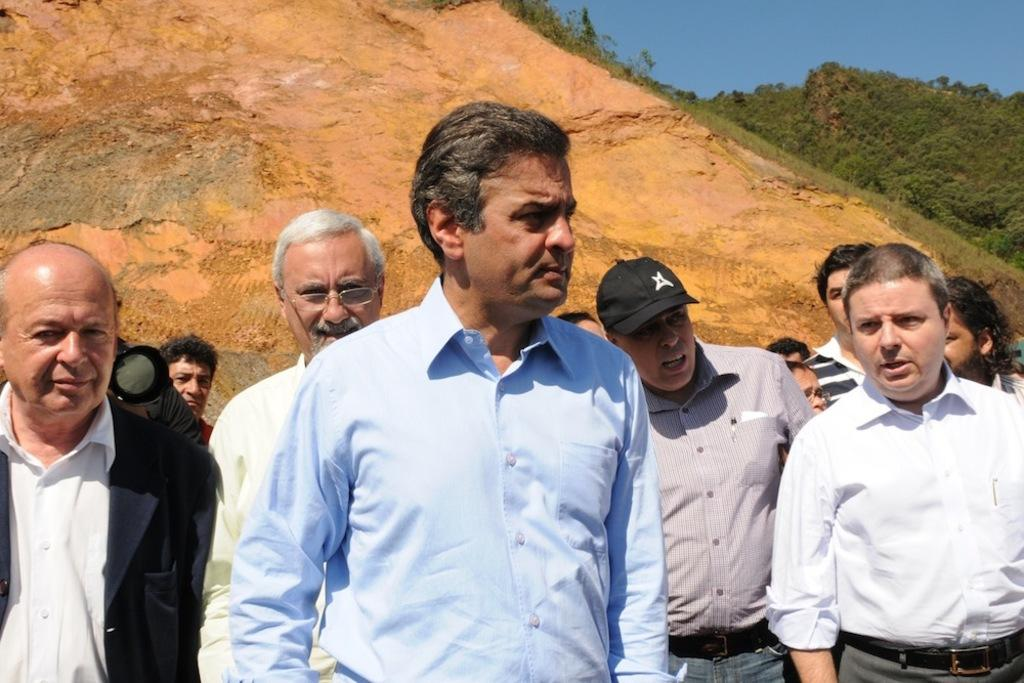How many people are in the image? There is a group of people standing in the image. What is one person in the group doing? One person is holding a camera. What can be seen in the background of the image? There is a group of trees and a hill visible in the background. How would you describe the weather based on the image? The sky appears cloudy in the image. Can you see any skateboards being used by the group in the image? There is no mention of skateboards or any similar objects in the image. 